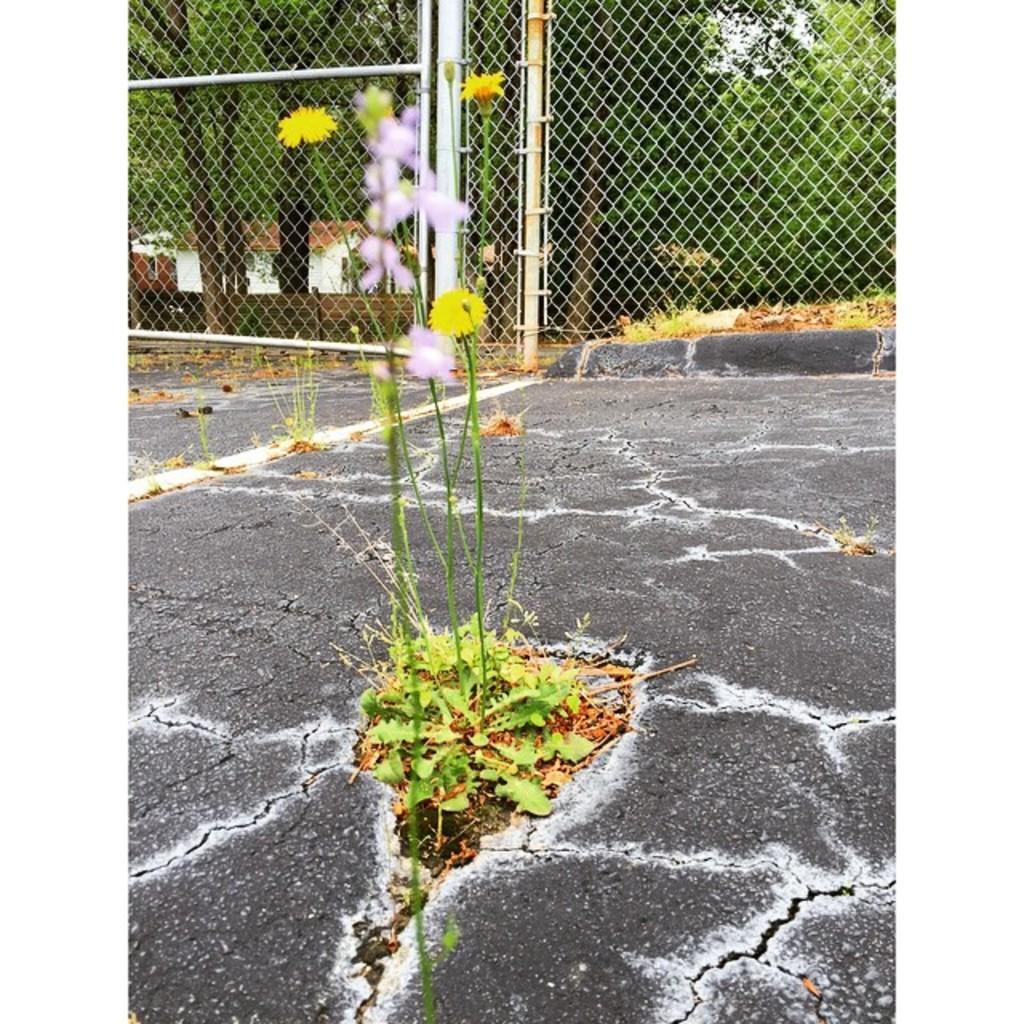Can you describe this image briefly? In this image we can see one house in the background, one fence, some objects on the ground, one road, some trees in the background, few plants with flowers on the ground, some plants and grass on the ground. 